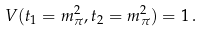Convert formula to latex. <formula><loc_0><loc_0><loc_500><loc_500>V ( t _ { 1 } = m _ { \pi } ^ { 2 } , t _ { 2 } = m _ { \pi } ^ { 2 } ) = 1 \, .</formula> 